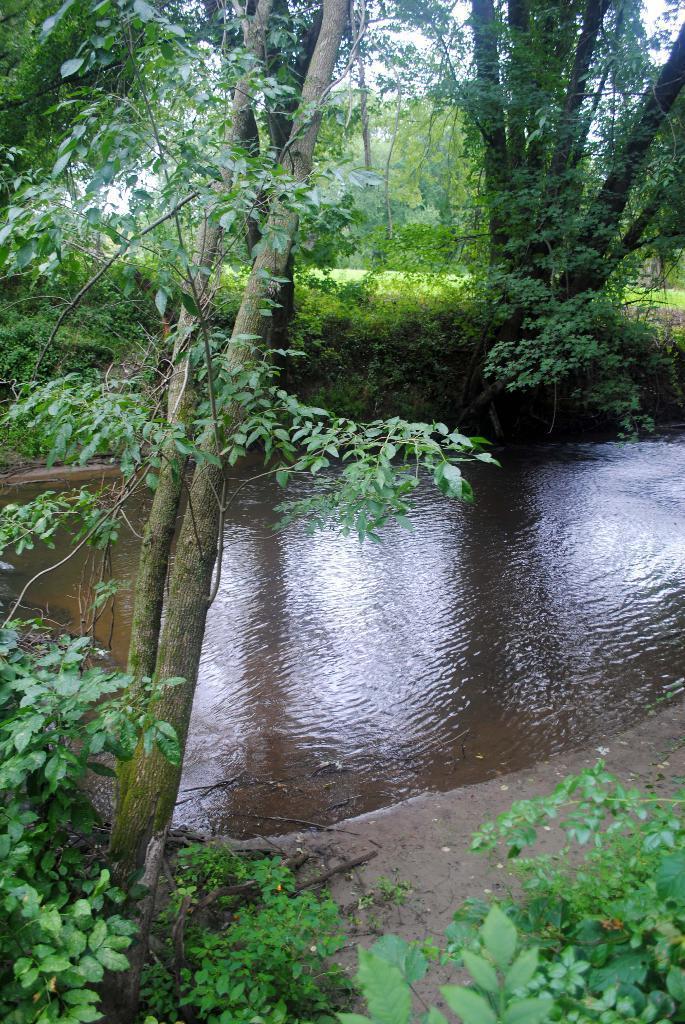Can you describe this image briefly? In this image, we can see so many trees, plants. In the middle of the image, we can see water. Background there is a sky. 